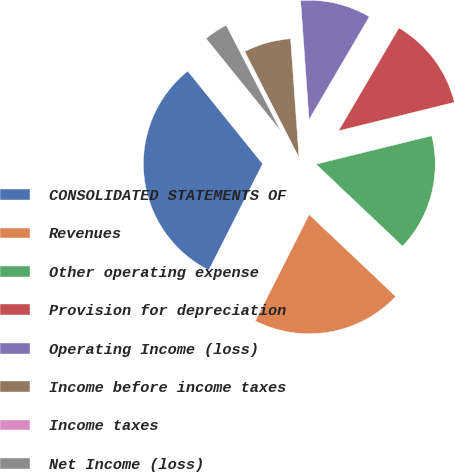Convert chart to OTSL. <chart><loc_0><loc_0><loc_500><loc_500><pie_chart><fcel>CONSOLIDATED STATEMENTS OF<fcel>Revenues<fcel>Other operating expense<fcel>Provision for depreciation<fcel>Operating Income (loss)<fcel>Income before income taxes<fcel>Income taxes<fcel>Net Income (loss)<nl><fcel>31.73%<fcel>20.39%<fcel>15.9%<fcel>12.73%<fcel>9.56%<fcel>6.4%<fcel>0.06%<fcel>3.23%<nl></chart> 